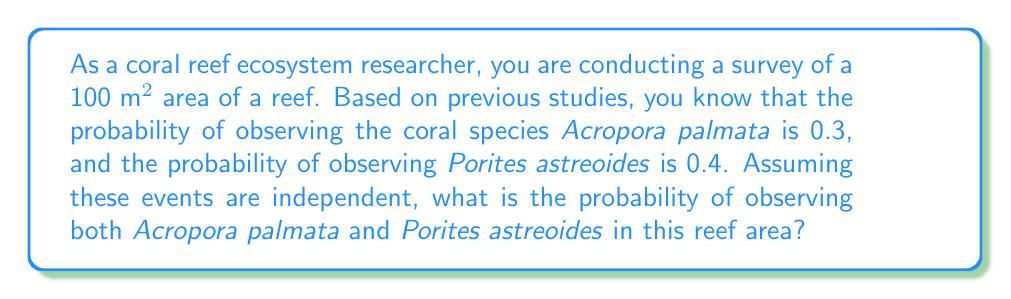Could you help me with this problem? To solve this problem, we need to use the multiplication rule for independent events. Since we are told that the events are independent, we can multiply the individual probabilities to find the probability of both events occurring together.

Let's define our events:
A = observing Acropora palmata
B = observing Porites astreoides

Given:
P(A) = 0.3
P(B) = 0.4

We want to find P(A and B), which is the probability of both events occurring.

For independent events, the probability of both events occurring is the product of their individual probabilities:

$$P(A \text{ and } B) = P(A) \times P(B)$$

Substituting the given probabilities:

$$P(A \text{ and } B) = 0.3 \times 0.4$$

$$P(A \text{ and } B) = 0.12$$

Therefore, the probability of observing both Acropora palmata and Porites astreoides in the given reef area is 0.12 or 12%.
Answer: 0.12 or 12% 